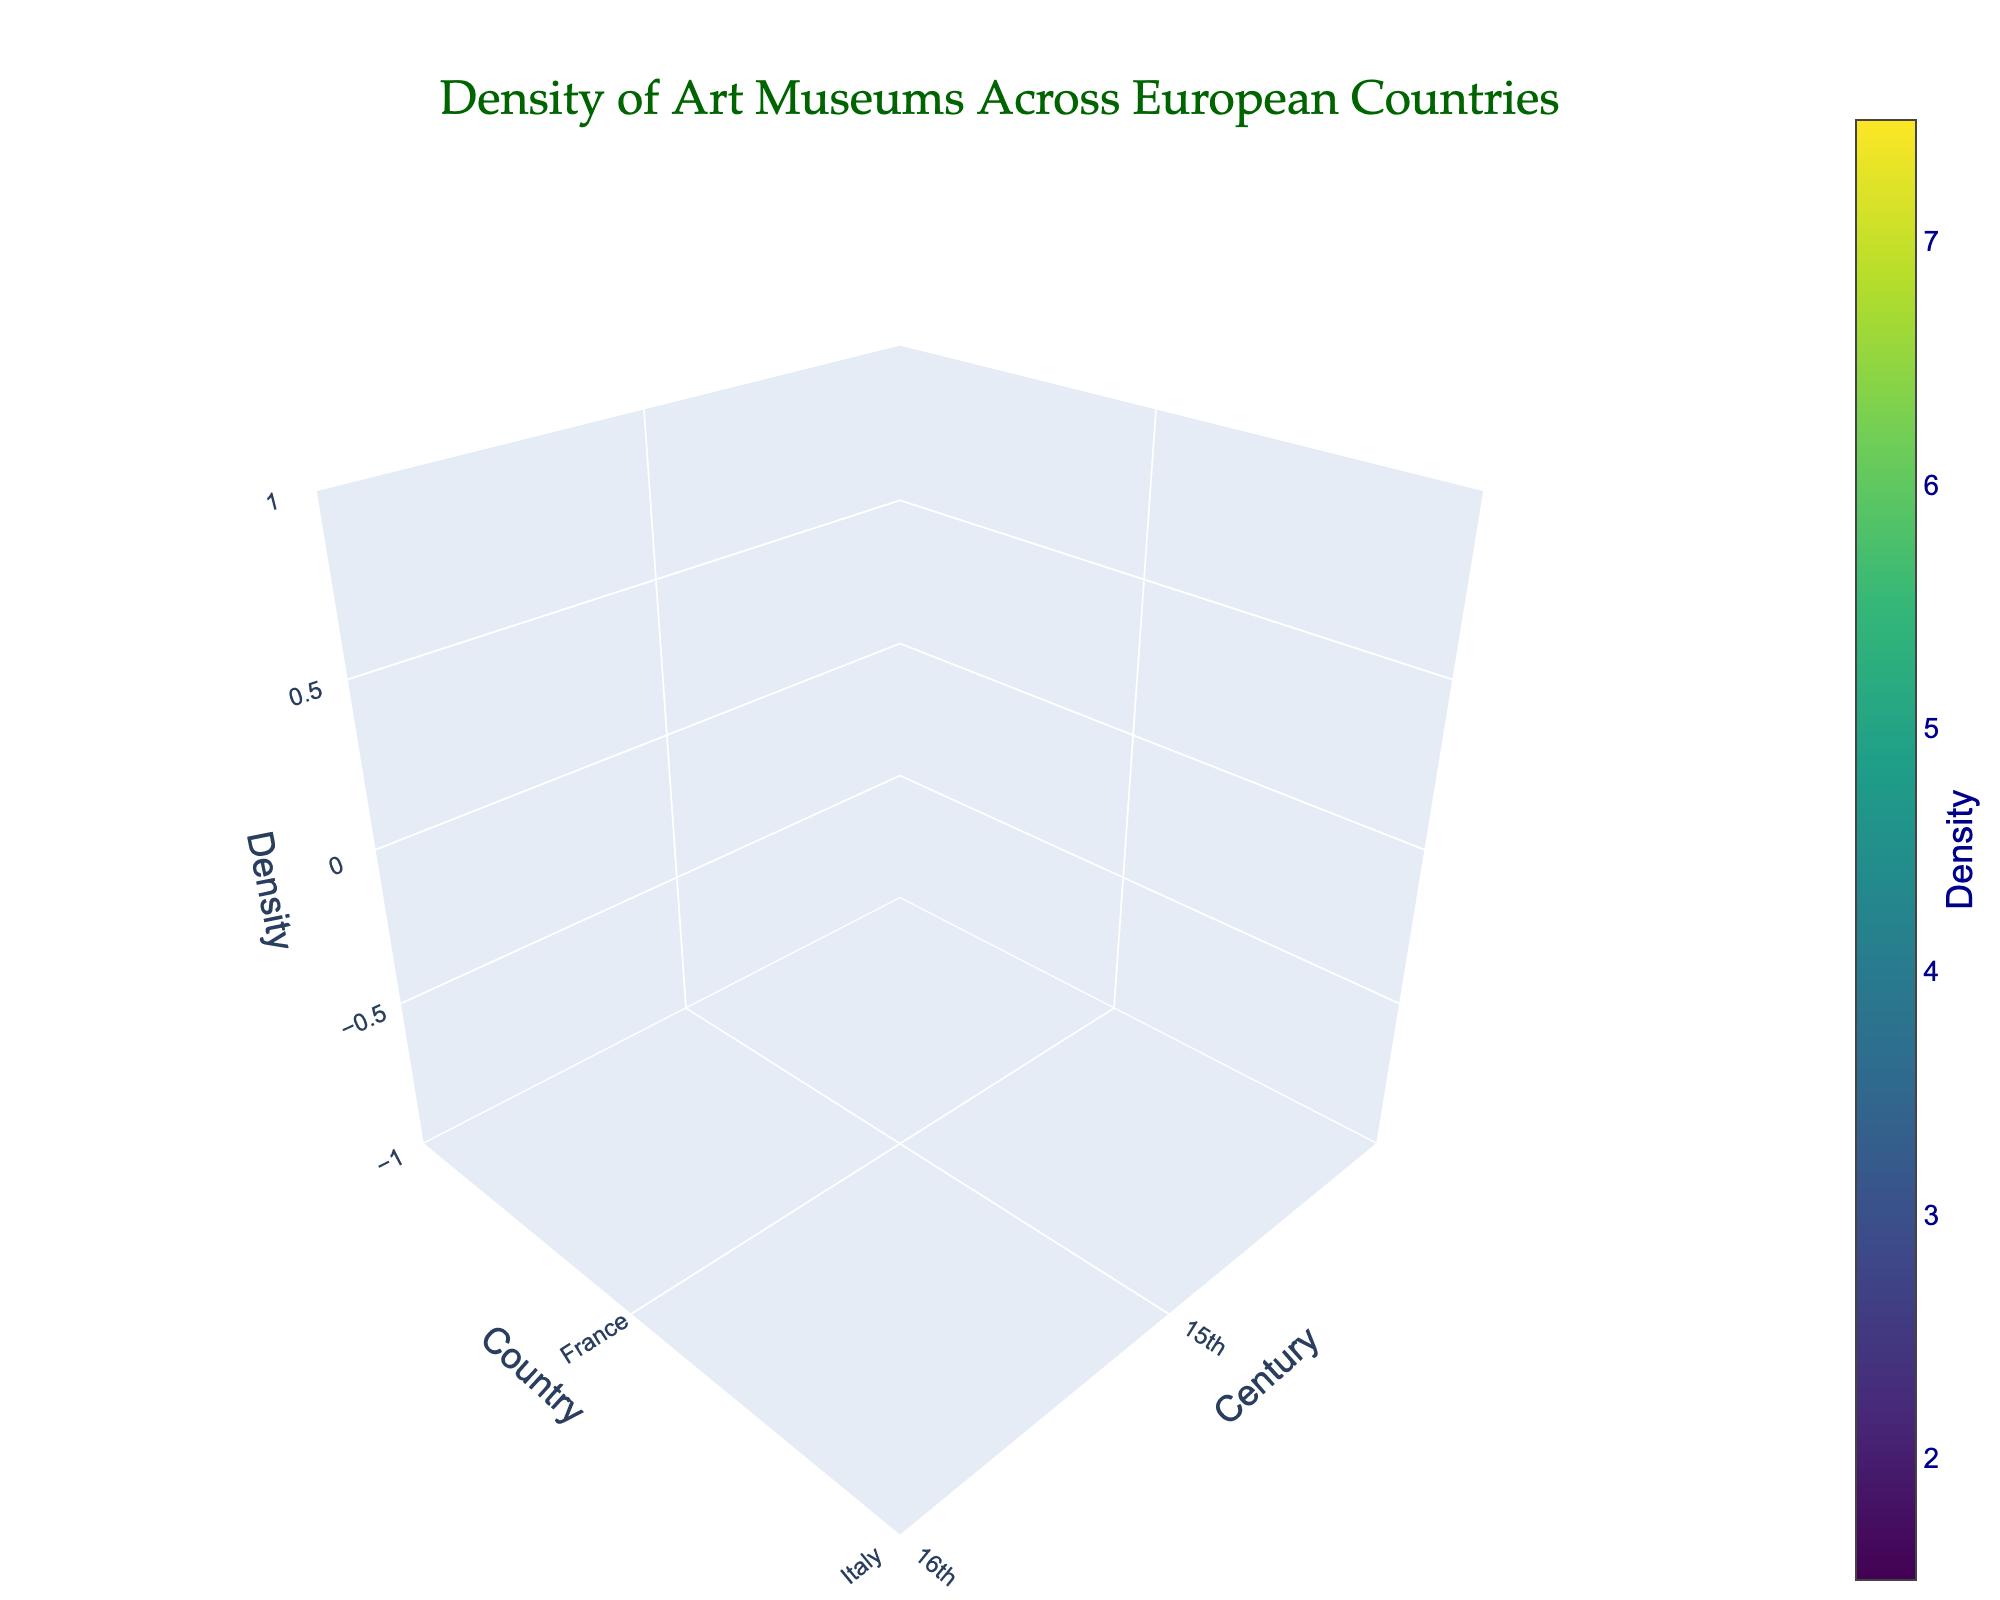How many countries are represented in the plot? The plot categorizes data by country, and visually, we can count the different countries represented on the y-axis.
Answer: 5 What does the x-axis represent? The x-axis of the plot denotes centuries, showing different time periods in the primary collections of art museums.
Answer: Century Which country has the highest museum density in the 19th century? To determine this, observe the 19th-century data along the x-axis and identify the country with the highest z-axis value.
Answer: Italy What is the range of densities shown in the color scale? The color scale shows density values transitioning from one extreme to another, indicated by the isomin and isomax values.
Answer: 1.5 to 7.5 What is the general trend of museum density in European countries from the 15th to the 19th century? By observing the x-axis progression from the 15th to 19th centuries, we can see an upward trend in the density values, suggesting increasing density over time.
Answer: Increasing Compare the density of art museums in France and Italy during the 17th century. Locate France and Italy on the y-axis and then follow their respective densities for the 17th century on the z-axis. France's density is 4.5 and Italy's density is 5.1.
Answer: Italy has a higher density Which country shows the most significant increase in museum density from the 15th to the 19th century? To determine this, calculate the difference in densities for the 15th and 19th centuries for each country and compare the changes. Italy: 7.2-3.5=3.7, France: 6.8-2.3=4.5, etc. France shows the most significant increase of 4.5.
Answer: France What's the median density value for the United Kingdom across all centuries? List the densities for the United Kingdom (1.6, 2.4, 3.2, 4.1, 5.7), arrange them in order, and find the middle value.
Answer: 3.2 In which century do the Netherlands and Spain have the closest museum densities? Compare the density values of the Netherlands and Spain across all centuries to find the smallest difference. In the 16th century, the densities are 2.7 (Netherlands) and 2.9 (Spain), yielding the closest value difference of 0.2.
Answer: 16th Century What is the average museum density in Italy for the 16th and 17th centuries combined? Take the density values for Italy in these two centuries (4.2 and 5.1), sum them (4.2 + 5.1 = 9.3), and then divide by 2 to get the average.
Answer: 4.65 